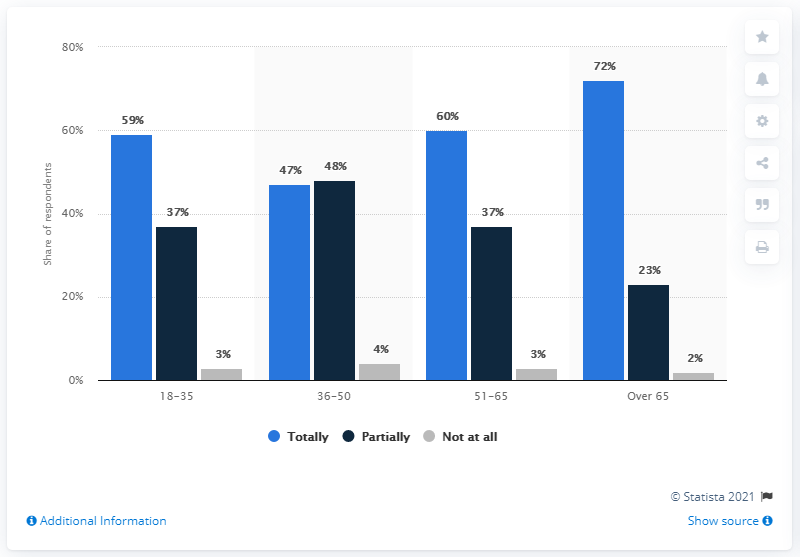Draw attention to some important aspects in this diagram. This data includes four age groups. The average number of people who have stated that they have remained at home "totally" during the pandemic is 59.5%. 